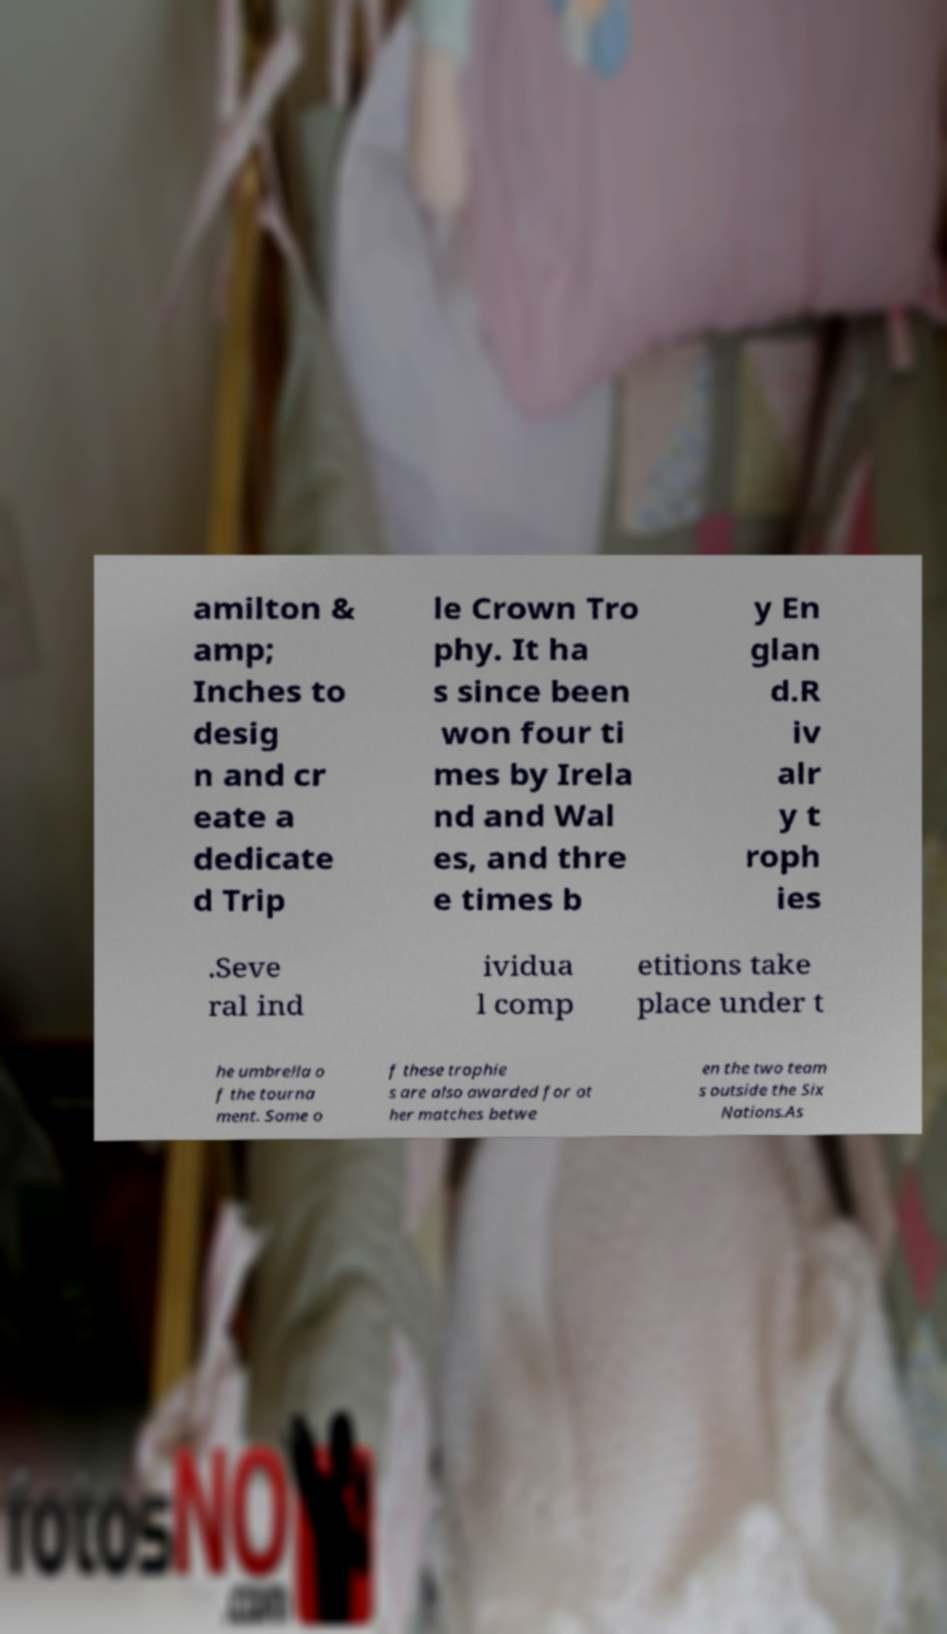Please read and relay the text visible in this image. What does it say? amilton & amp; Inches to desig n and cr eate a dedicate d Trip le Crown Tro phy. It ha s since been won four ti mes by Irela nd and Wal es, and thre e times b y En glan d.R iv alr y t roph ies .Seve ral ind ividua l comp etitions take place under t he umbrella o f the tourna ment. Some o f these trophie s are also awarded for ot her matches betwe en the two team s outside the Six Nations.As 